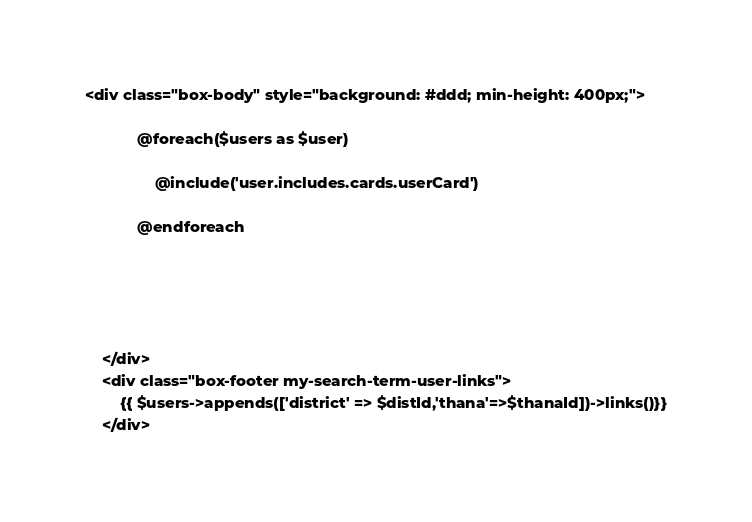<code> <loc_0><loc_0><loc_500><loc_500><_PHP_><div class="box-body" style="background: #ddd; min-height: 400px;">
 
            @foreach($users as $user)
 
                @include('user.includes.cards.userCard')
 
            @endforeach
 
 

        

    </div>
    <div class="box-footer my-search-term-user-links">
        {{ $users->appends(['district' => $distId,'thana'=>$thanaId])->links()}}
    </div></code> 